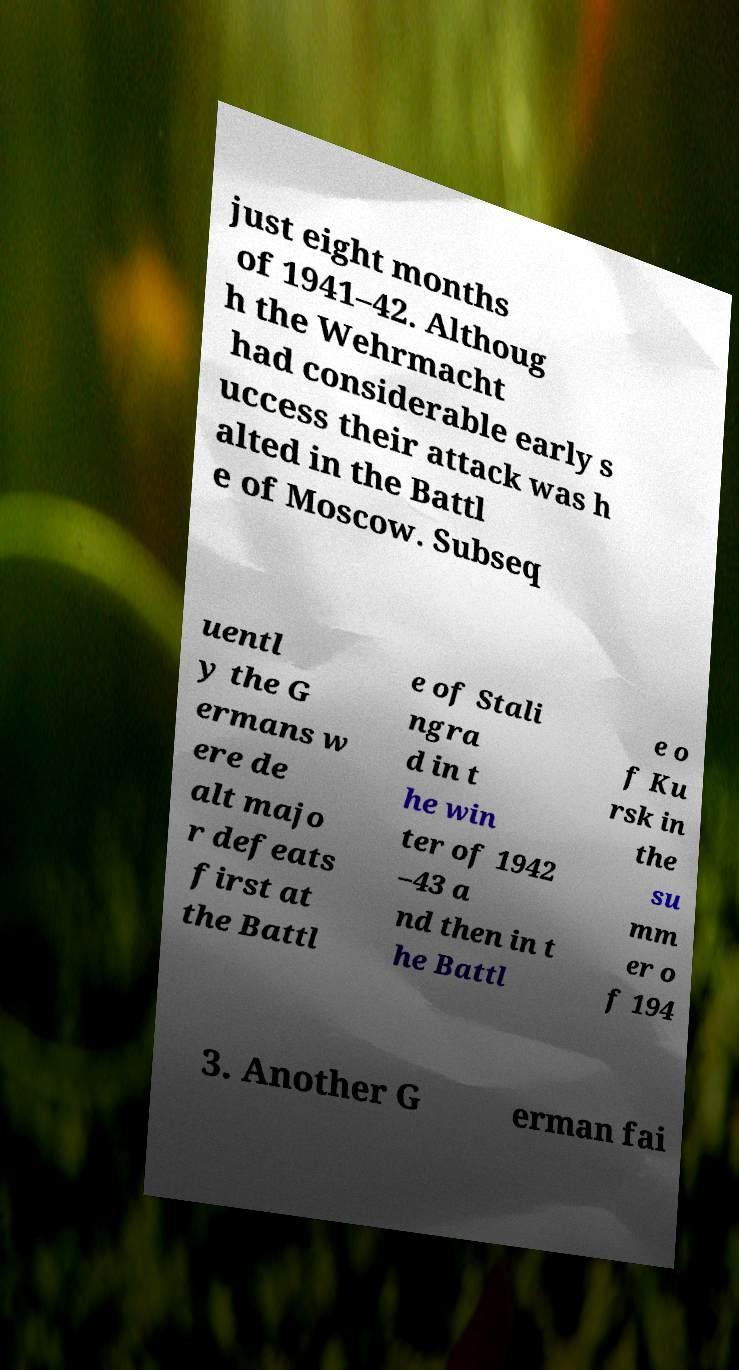I need the written content from this picture converted into text. Can you do that? just eight months of 1941–42. Althoug h the Wehrmacht had considerable early s uccess their attack was h alted in the Battl e of Moscow. Subseq uentl y the G ermans w ere de alt majo r defeats first at the Battl e of Stali ngra d in t he win ter of 1942 –43 a nd then in t he Battl e o f Ku rsk in the su mm er o f 194 3. Another G erman fai 